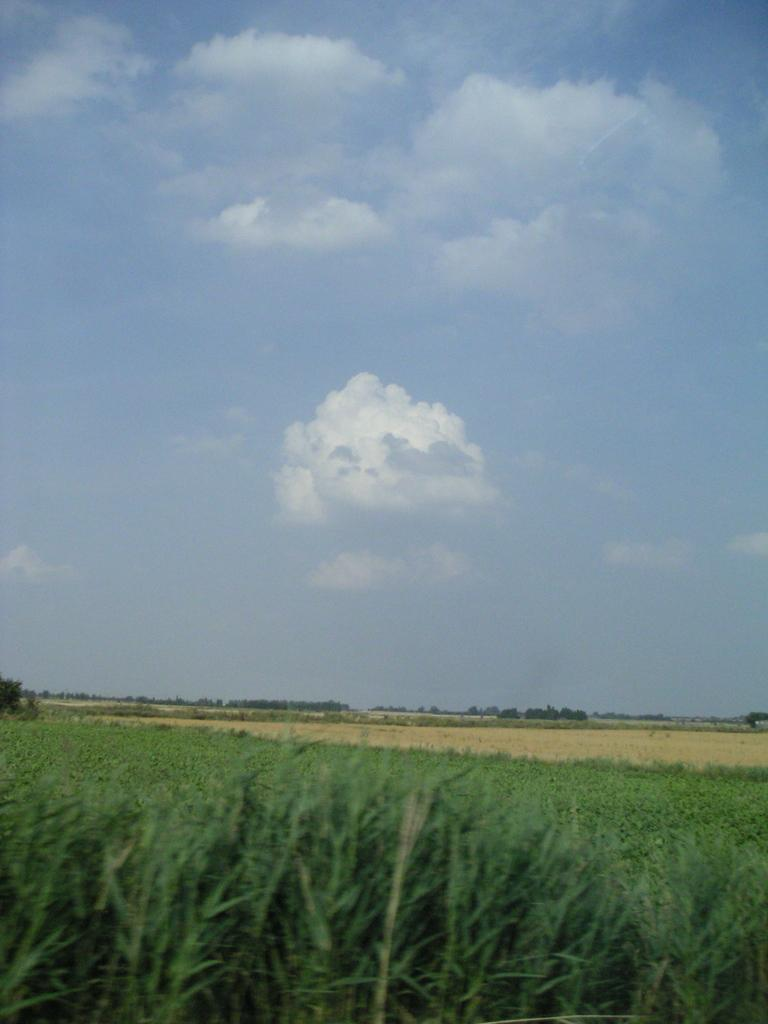What celestial bodies can be seen at the bottom of the image? There are planets visible at the bottom of the image. What is visible in the background of the image? Sky is visible in the background of the image. What can be observed in the sky? Clouds are present in the sky. What type of soda is being poured over the plants in the image? There are no plants or soda present in the image; it only features planets and sky with clouds. 